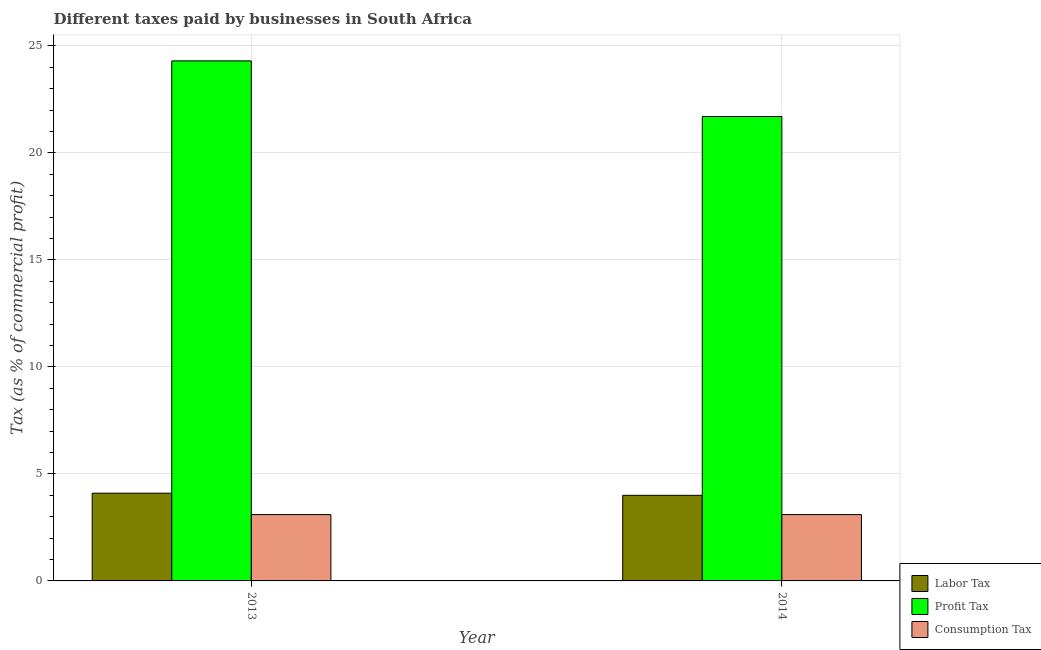How many different coloured bars are there?
Give a very brief answer. 3. What is the label of the 2nd group of bars from the left?
Ensure brevity in your answer.  2014. What is the percentage of labor tax in 2013?
Keep it short and to the point. 4.1. Across all years, what is the maximum percentage of labor tax?
Your response must be concise. 4.1. What is the total percentage of consumption tax in the graph?
Your answer should be very brief. 6.2. What is the difference between the percentage of profit tax in 2013 and that in 2014?
Offer a very short reply. 2.6. What is the ratio of the percentage of profit tax in 2013 to that in 2014?
Offer a very short reply. 1.12. Is the percentage of consumption tax in 2013 less than that in 2014?
Your answer should be compact. No. In how many years, is the percentage of profit tax greater than the average percentage of profit tax taken over all years?
Your answer should be compact. 1. What does the 1st bar from the left in 2013 represents?
Offer a terse response. Labor Tax. What does the 2nd bar from the right in 2014 represents?
Provide a short and direct response. Profit Tax. Is it the case that in every year, the sum of the percentage of labor tax and percentage of profit tax is greater than the percentage of consumption tax?
Your answer should be very brief. Yes. How many years are there in the graph?
Your answer should be compact. 2. What is the title of the graph?
Offer a terse response. Different taxes paid by businesses in South Africa. What is the label or title of the X-axis?
Give a very brief answer. Year. What is the label or title of the Y-axis?
Ensure brevity in your answer.  Tax (as % of commercial profit). What is the Tax (as % of commercial profit) in Labor Tax in 2013?
Your answer should be compact. 4.1. What is the Tax (as % of commercial profit) of Profit Tax in 2013?
Your answer should be very brief. 24.3. What is the Tax (as % of commercial profit) in Labor Tax in 2014?
Your response must be concise. 4. What is the Tax (as % of commercial profit) in Profit Tax in 2014?
Offer a very short reply. 21.7. What is the Tax (as % of commercial profit) in Consumption Tax in 2014?
Provide a succinct answer. 3.1. Across all years, what is the maximum Tax (as % of commercial profit) in Profit Tax?
Give a very brief answer. 24.3. Across all years, what is the maximum Tax (as % of commercial profit) in Consumption Tax?
Keep it short and to the point. 3.1. Across all years, what is the minimum Tax (as % of commercial profit) in Profit Tax?
Your answer should be compact. 21.7. Across all years, what is the minimum Tax (as % of commercial profit) of Consumption Tax?
Provide a short and direct response. 3.1. What is the total Tax (as % of commercial profit) of Labor Tax in the graph?
Give a very brief answer. 8.1. What is the total Tax (as % of commercial profit) of Profit Tax in the graph?
Provide a short and direct response. 46. What is the total Tax (as % of commercial profit) of Consumption Tax in the graph?
Provide a succinct answer. 6.2. What is the difference between the Tax (as % of commercial profit) of Profit Tax in 2013 and that in 2014?
Offer a terse response. 2.6. What is the difference between the Tax (as % of commercial profit) in Consumption Tax in 2013 and that in 2014?
Offer a very short reply. 0. What is the difference between the Tax (as % of commercial profit) of Labor Tax in 2013 and the Tax (as % of commercial profit) of Profit Tax in 2014?
Offer a terse response. -17.6. What is the difference between the Tax (as % of commercial profit) of Labor Tax in 2013 and the Tax (as % of commercial profit) of Consumption Tax in 2014?
Offer a terse response. 1. What is the difference between the Tax (as % of commercial profit) in Profit Tax in 2013 and the Tax (as % of commercial profit) in Consumption Tax in 2014?
Offer a very short reply. 21.2. What is the average Tax (as % of commercial profit) in Labor Tax per year?
Your answer should be very brief. 4.05. In the year 2013, what is the difference between the Tax (as % of commercial profit) of Labor Tax and Tax (as % of commercial profit) of Profit Tax?
Keep it short and to the point. -20.2. In the year 2013, what is the difference between the Tax (as % of commercial profit) in Profit Tax and Tax (as % of commercial profit) in Consumption Tax?
Your answer should be very brief. 21.2. In the year 2014, what is the difference between the Tax (as % of commercial profit) of Labor Tax and Tax (as % of commercial profit) of Profit Tax?
Provide a short and direct response. -17.7. In the year 2014, what is the difference between the Tax (as % of commercial profit) in Profit Tax and Tax (as % of commercial profit) in Consumption Tax?
Give a very brief answer. 18.6. What is the ratio of the Tax (as % of commercial profit) of Labor Tax in 2013 to that in 2014?
Offer a terse response. 1.02. What is the ratio of the Tax (as % of commercial profit) in Profit Tax in 2013 to that in 2014?
Your answer should be very brief. 1.12. What is the ratio of the Tax (as % of commercial profit) of Consumption Tax in 2013 to that in 2014?
Keep it short and to the point. 1. What is the difference between the highest and the second highest Tax (as % of commercial profit) of Labor Tax?
Give a very brief answer. 0.1. What is the difference between the highest and the second highest Tax (as % of commercial profit) of Profit Tax?
Provide a succinct answer. 2.6. What is the difference between the highest and the second highest Tax (as % of commercial profit) in Consumption Tax?
Your answer should be compact. 0. What is the difference between the highest and the lowest Tax (as % of commercial profit) of Labor Tax?
Your response must be concise. 0.1. 